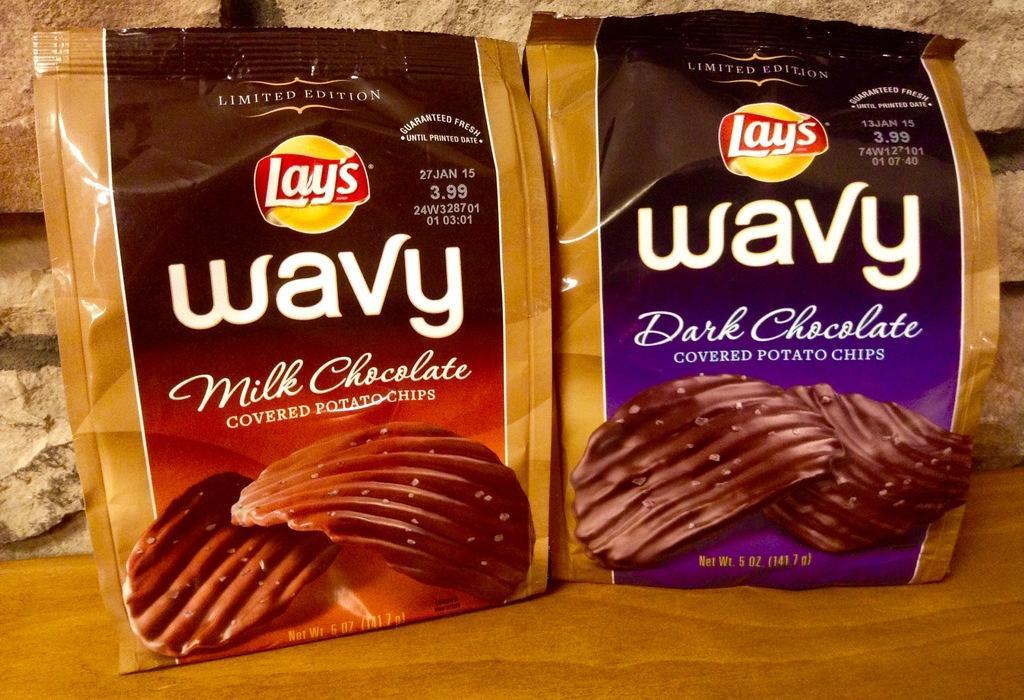In one or two sentences, can you explain what this image depicts? In this image there are packets with some text written on it. In the background there is a wall. 